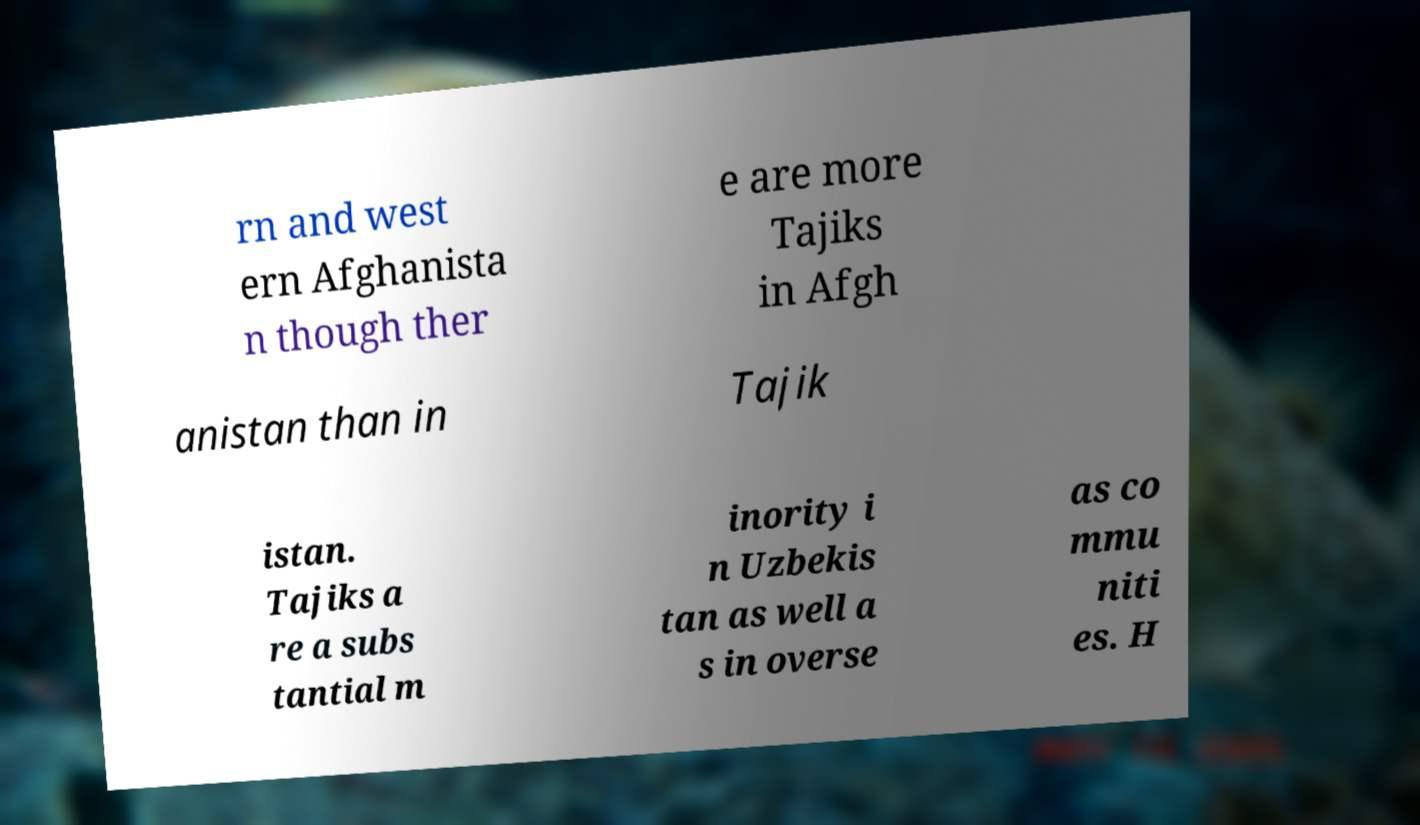Could you extract and type out the text from this image? rn and west ern Afghanista n though ther e are more Tajiks in Afgh anistan than in Tajik istan. Tajiks a re a subs tantial m inority i n Uzbekis tan as well a s in overse as co mmu niti es. H 